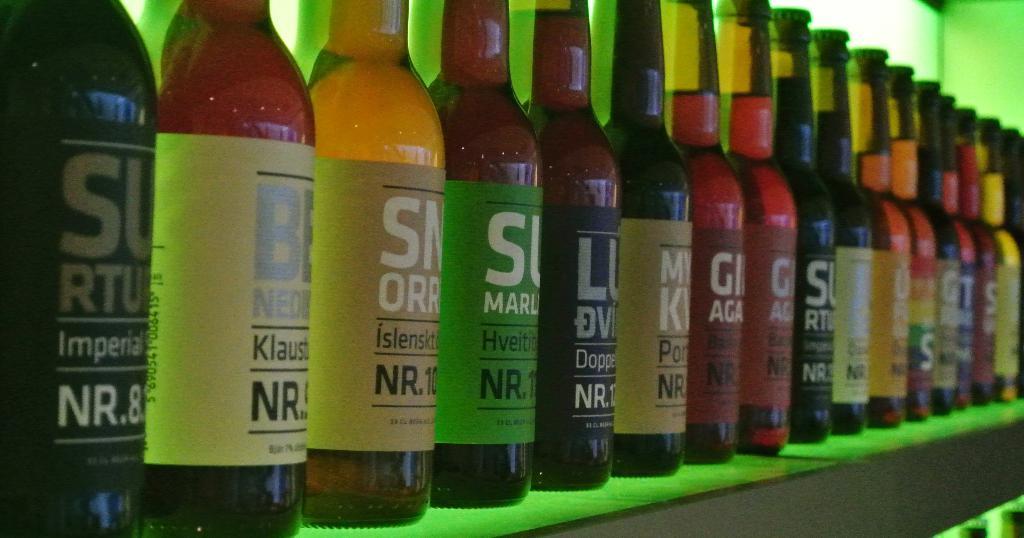What flavors are available?
Give a very brief answer. Unanswerable. 